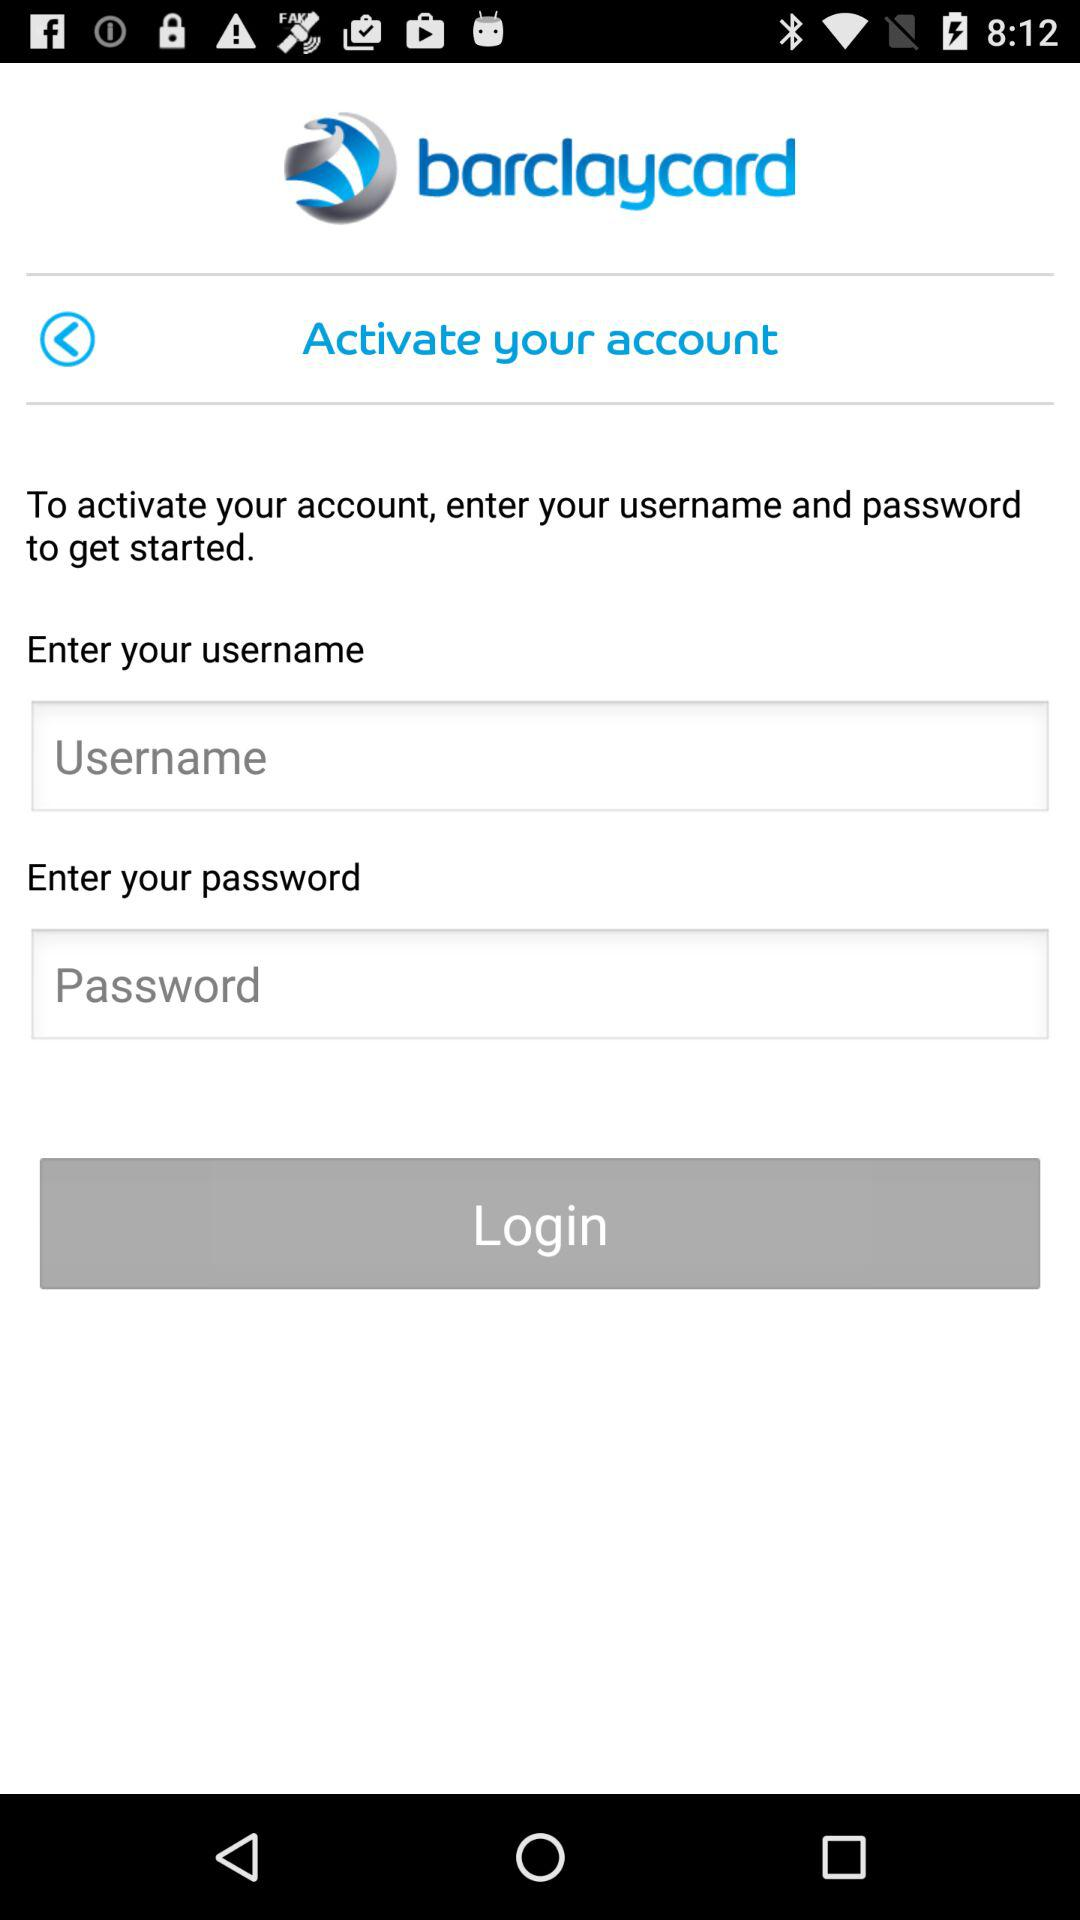How long must the password be?
When the provided information is insufficient, respond with <no answer>. <no answer> 